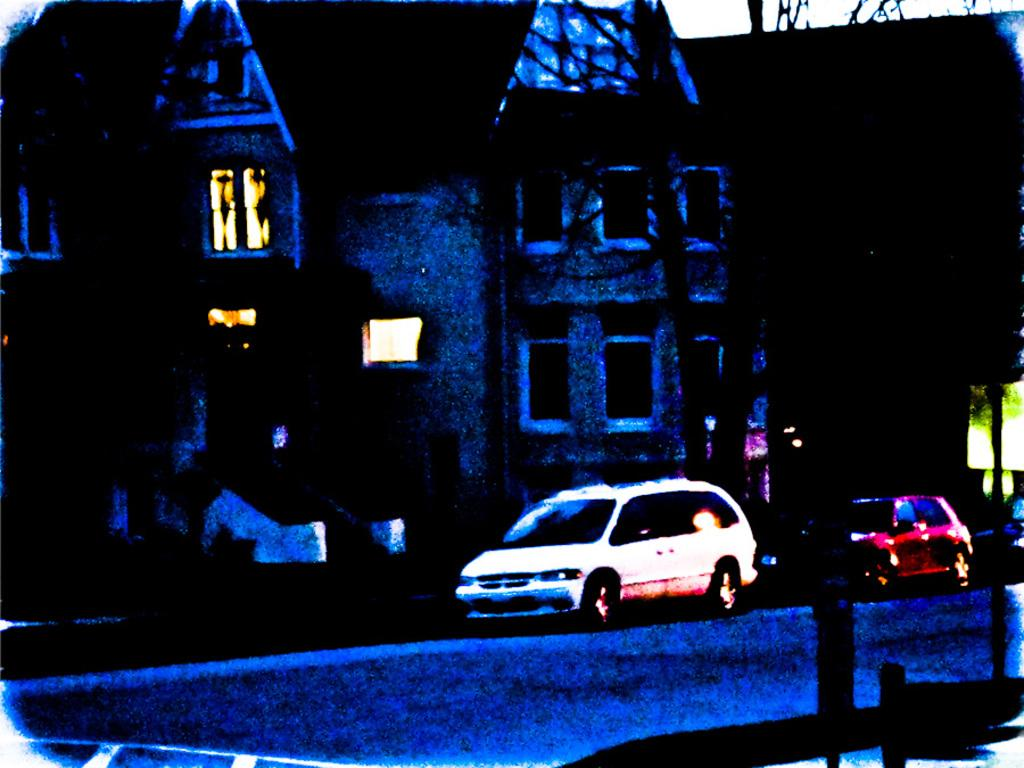What type of structures can be seen in the image? There are buildings in the image. What else can be seen besides the buildings? There are pipelines and a road in the image. What type of transportation might be using the road in the image? Motor vehicles are present in the image. Where is the drawer located in the image? There is no drawer present in the image. Can you see any cattle in the image? There are no cattle present in the image. 